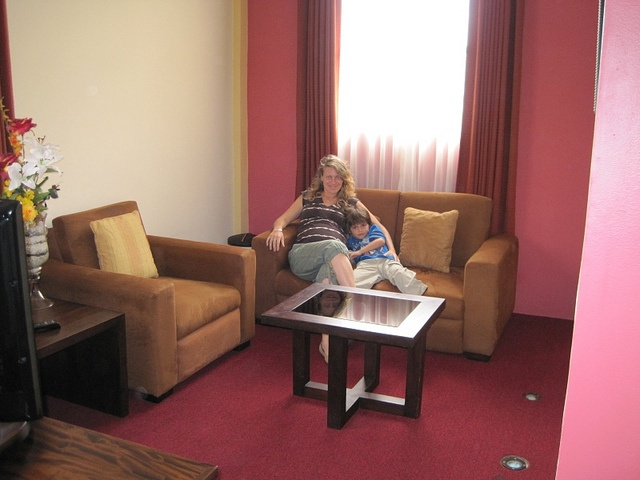Describe the objects in this image and their specific colors. I can see chair in maroon and brown tones, couch in maroon and brown tones, people in maroon, gray, brown, and tan tones, tv in maroon, black, and gray tones, and people in maroon, darkgray, gray, and lightgray tones in this image. 